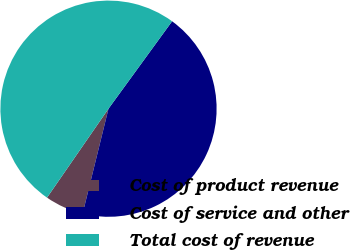Convert chart to OTSL. <chart><loc_0><loc_0><loc_500><loc_500><pie_chart><fcel>Cost of product revenue<fcel>Cost of service and other<fcel>Total cost of revenue<nl><fcel>5.78%<fcel>43.84%<fcel>50.39%<nl></chart> 